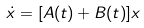<formula> <loc_0><loc_0><loc_500><loc_500>\dot { x } = [ A ( t ) + B ( t ) ] x</formula> 